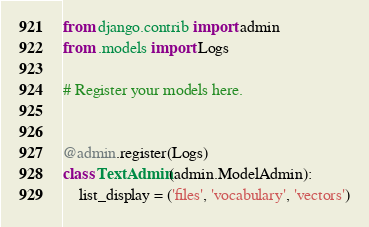Convert code to text. <code><loc_0><loc_0><loc_500><loc_500><_Python_>from django.contrib import admin
from .models import Logs

# Register your models here.


@admin.register(Logs)
class TextAdmin(admin.ModelAdmin):
    list_display = ('files', 'vocabulary', 'vectors')
</code> 